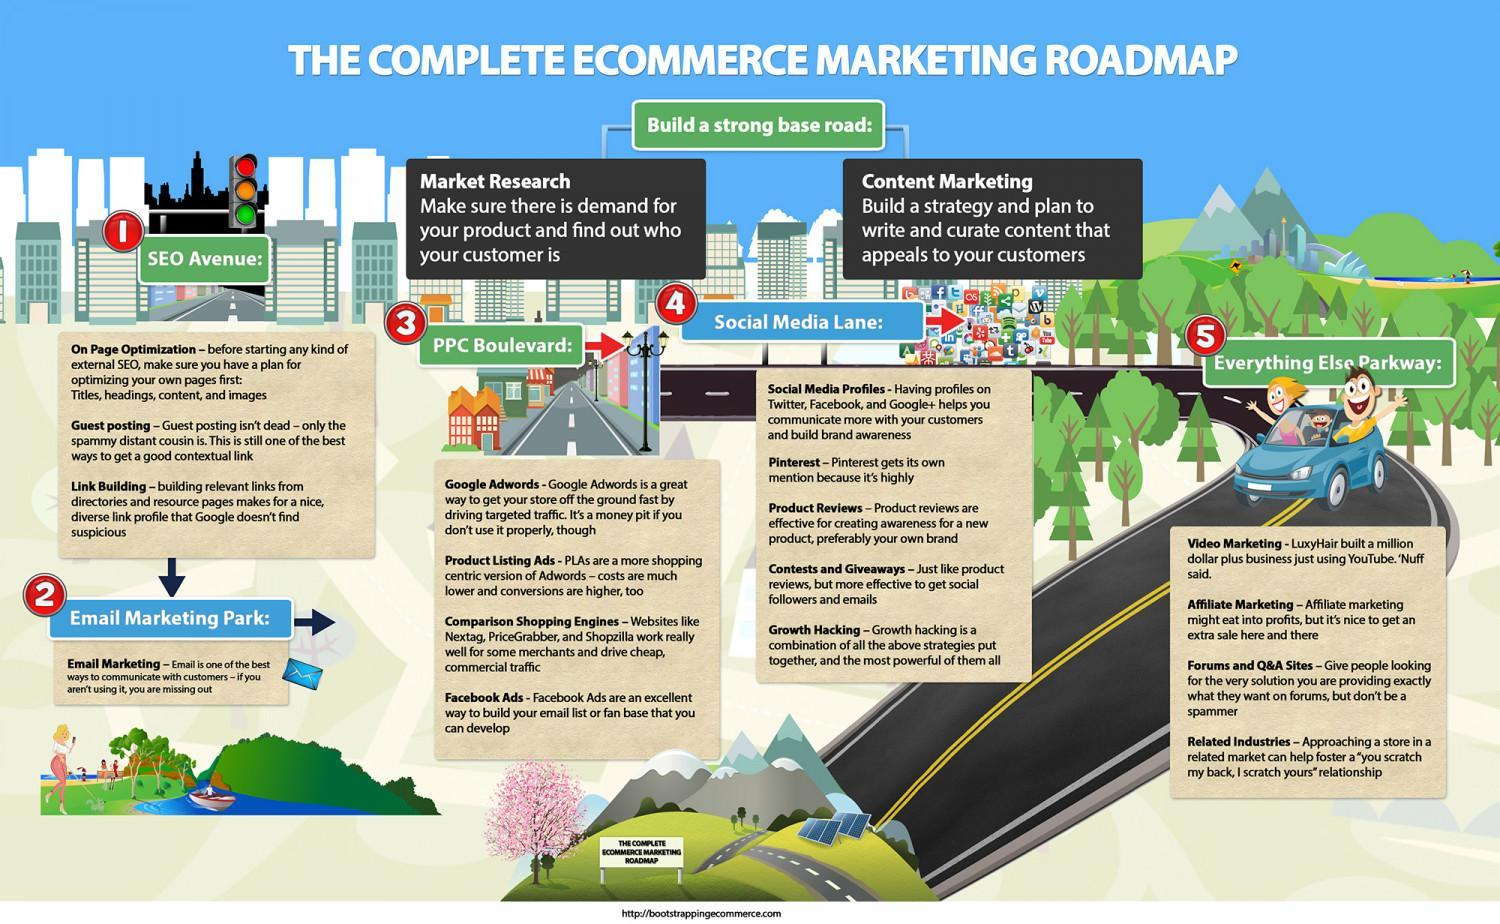What helps to find about demand for your product and about potential customers?
Answer the question with a short phrase. Market research What are Nextag, PriceGrabber and Shopzilla examples of? Comparison Shopping Engines Which is one the best ways to communicate with customers? Email What helps for creating awareness about product or brand? Product Reviews What helps in driving targeted traffic to your website? Google Adwords What are similar to Adwords, but more shopping oriented? Product Listing Ads What is an effective way to get social followers and emails? Contests and giveaways In which type of marketing can YouTube be used? Video Marketing What is the practice of optimizing your webpage's titles, headings, content and images called? On page optimization What means to build a strategy and create content that appeals to your customers? Content marketing 